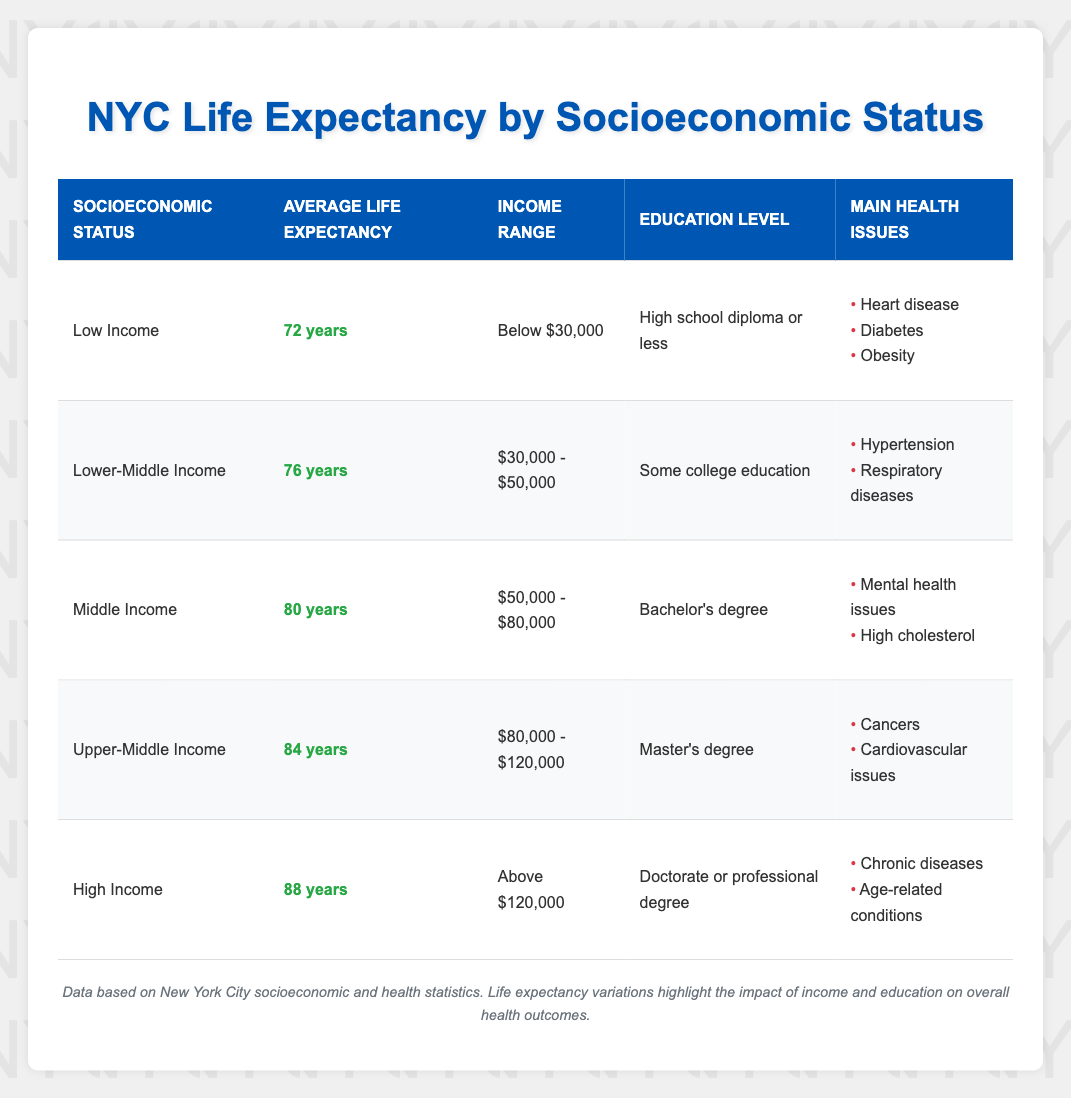What is the average life expectancy for someone in the High Income category? The High Income category has an average life expectancy listed in the table, which is 88 years.
Answer: 88 years Which socioeconomic status has the lowest average life expectancy? By reviewing the table, we see that the Low Income category has the lowest average life expectancy, which is 72 years.
Answer: Low Income What is the income range for individuals with a Middle Income status? The table shows that individuals with Middle Income status have an income range of $50,000 to $80,000.
Answer: $50,000 - $80,000 How many years do those in the Upper-Middle Income group live longer on average compared to those in the Lower-Middle Income group? The Upper-Middle Income group has an average life expectancy of 84 years, while the Lower-Middle Income group has 76 years. The difference is 84 - 76 = 8 years.
Answer: 8 years Is it true that individuals with a Master's degree belong to the Upper-Middle Income category? Referring to the table, those in the Upper-Middle Income category have a Master's degree as their education level, thus the statement is true.
Answer: Yes If we consider the average life expectancy of Low Income and High Income groups, what is the total? The average life expectancy for Low Income is 72 years and for High Income is 88 years. To find the total, we sum them: 72 + 88 = 160 years.
Answer: 160 years What are the main health issues for individuals in the Middle Income category? The table lists the main health issues for the Middle Income category as mental health issues and high cholesterol.
Answer: Mental health issues, high cholesterol Which socioeconomic status has a higher average life expectancy, Upper-Middle Income or Middle Income? Looking at the table, Upper-Middle Income has an average life expectancy of 84 years, while Middle Income has 80 years. Therefore, Upper-Middle Income has a higher life expectancy.
Answer: Upper-Middle Income What is the median income range across all socioeconomic statuses listed? The income ranges can be summarized as: Below $30,000, $30,000 - $50,000, $50,000 - $80,000, $80,000 - $120,000, Above $120,000. The ranges don’t correspond directly to numerical values. However, the middle ranges correspond to Middle Income ($50,000 - $80,000) and the Lower-Middle Income ($30,000 - $50,000), placing $50,000 - $80,000 roughly at the median.
Answer: $50,000 - $80,000 